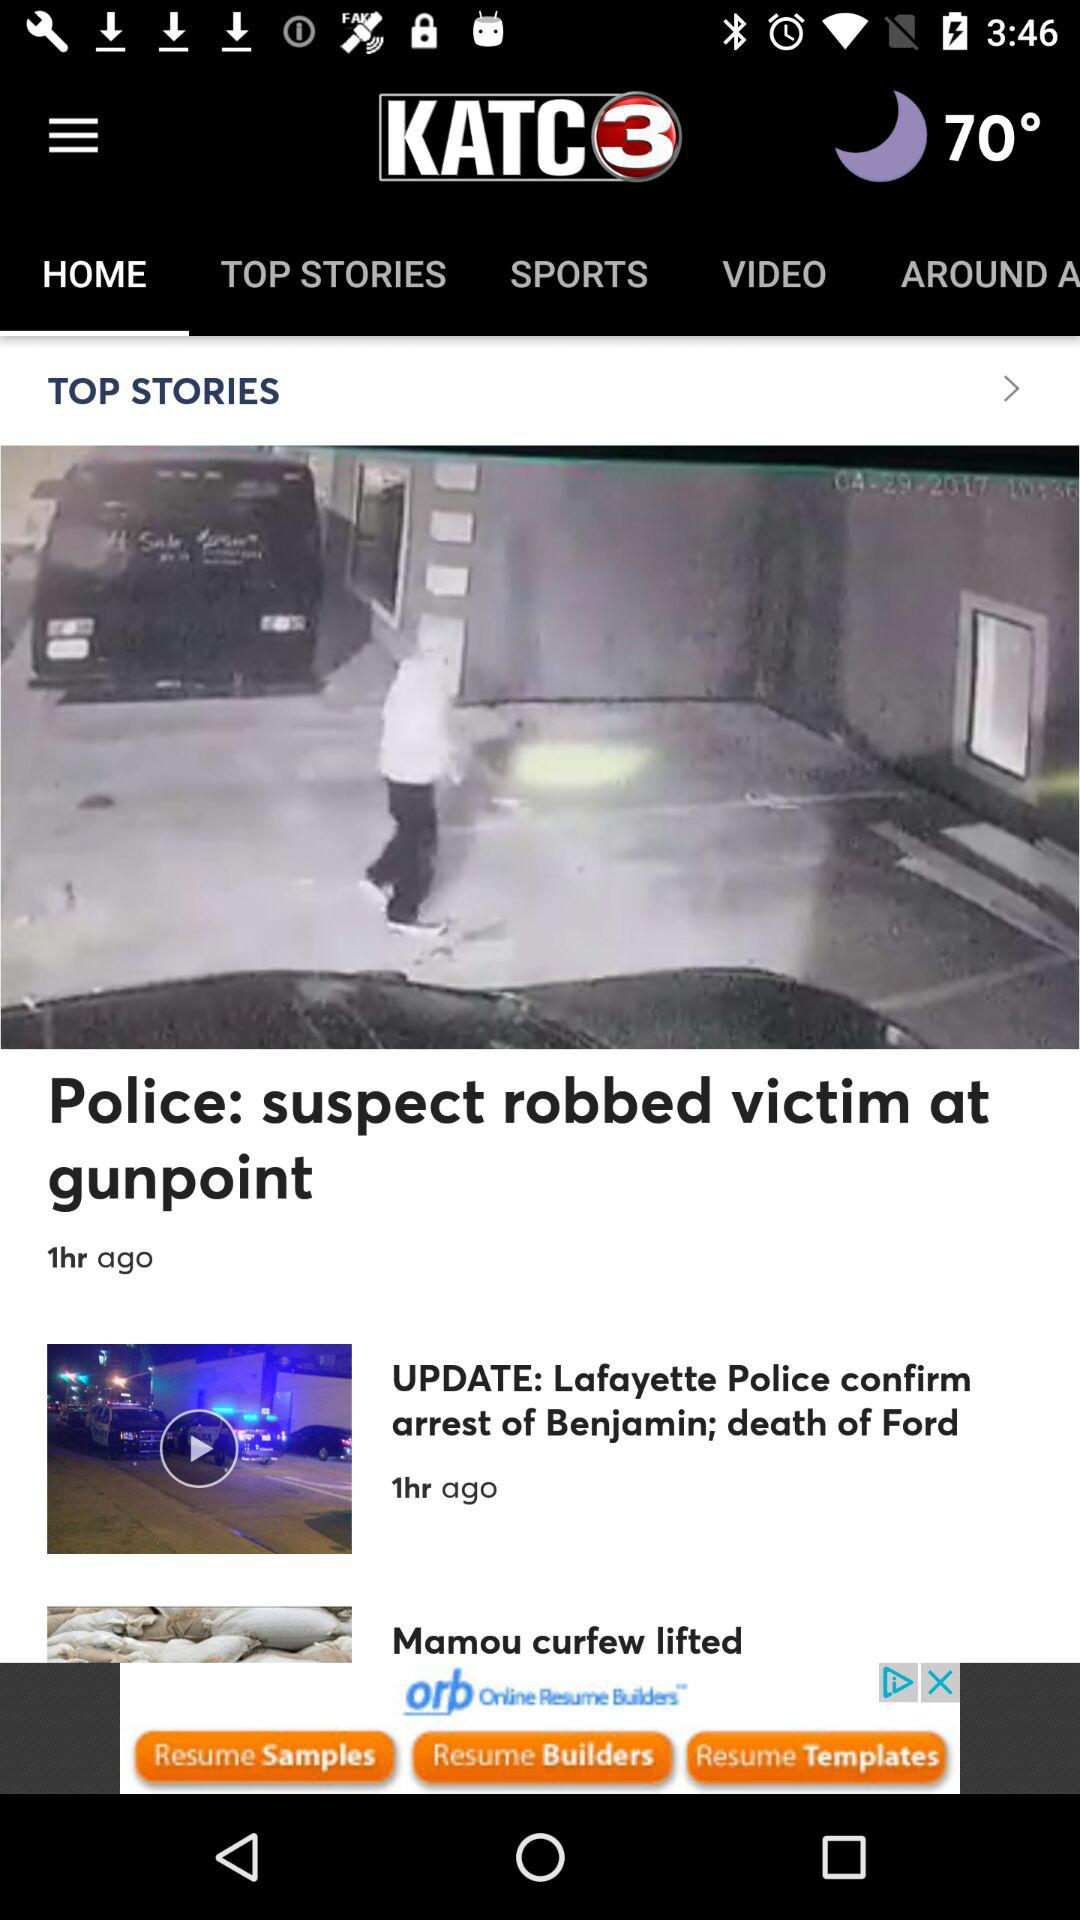When was the news "Police: suspect robbed victim at gunpoint" posted? The news "Police: suspect robbed victim at gunpoint" was posted 1 hour ago. 